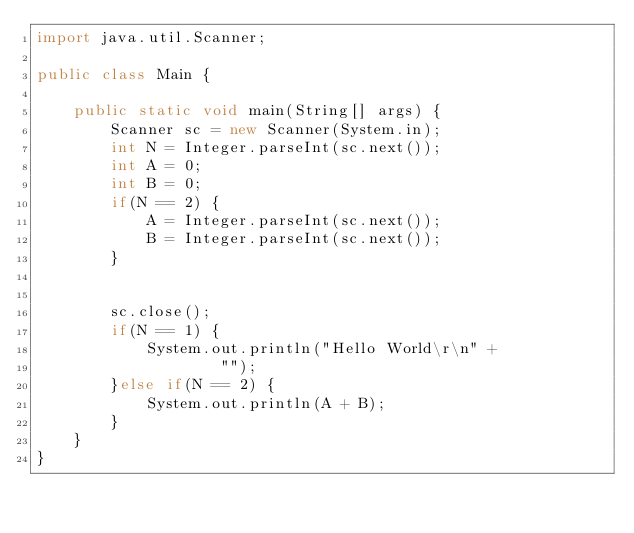<code> <loc_0><loc_0><loc_500><loc_500><_Java_>import java.util.Scanner;

public class Main {

	public static void main(String[] args) {
		Scanner sc = new Scanner(System.in);
		int N = Integer.parseInt(sc.next());
		int A = 0;
		int B = 0;
		if(N == 2) {
			A = Integer.parseInt(sc.next());
			B = Integer.parseInt(sc.next());
		}


		sc.close();
		if(N == 1) {
			System.out.println("Hello World\r\n" +
					"");
		}else if(N == 2) {
			System.out.println(A + B);
		}
	}
}</code> 